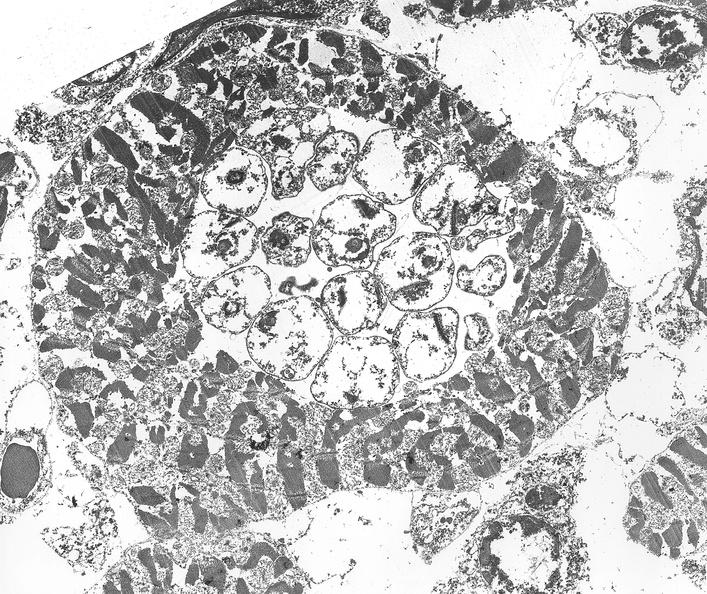s papillary intraductal adenocarcinoma present?
Answer the question using a single word or phrase. No 